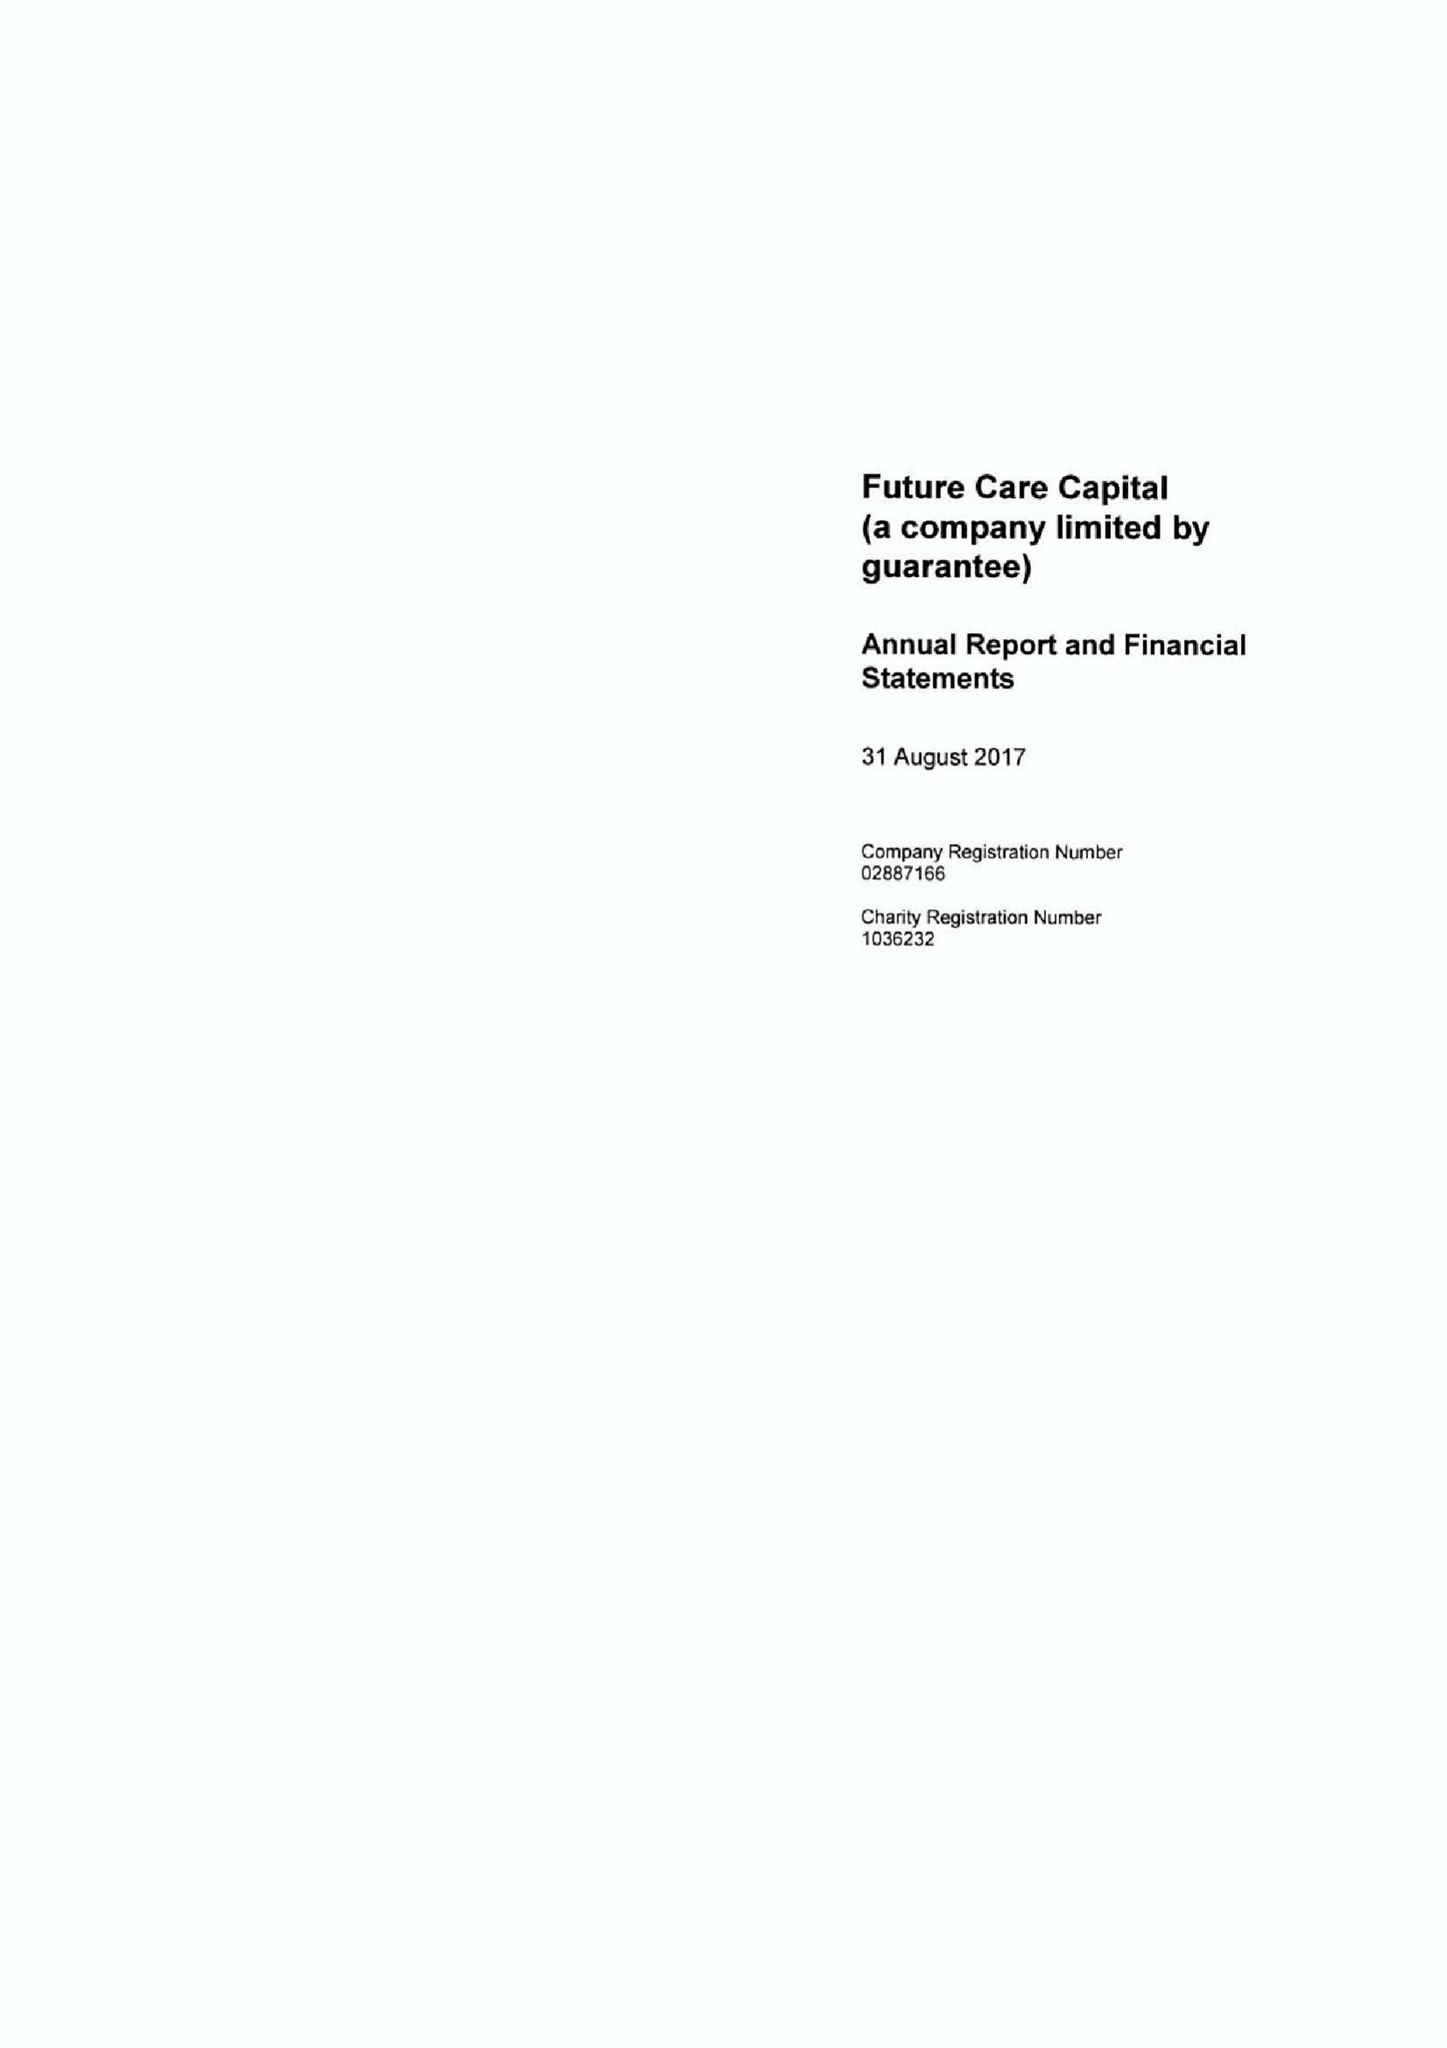What is the value for the address__postcode?
Answer the question using a single word or phrase. SW1V 1HU 